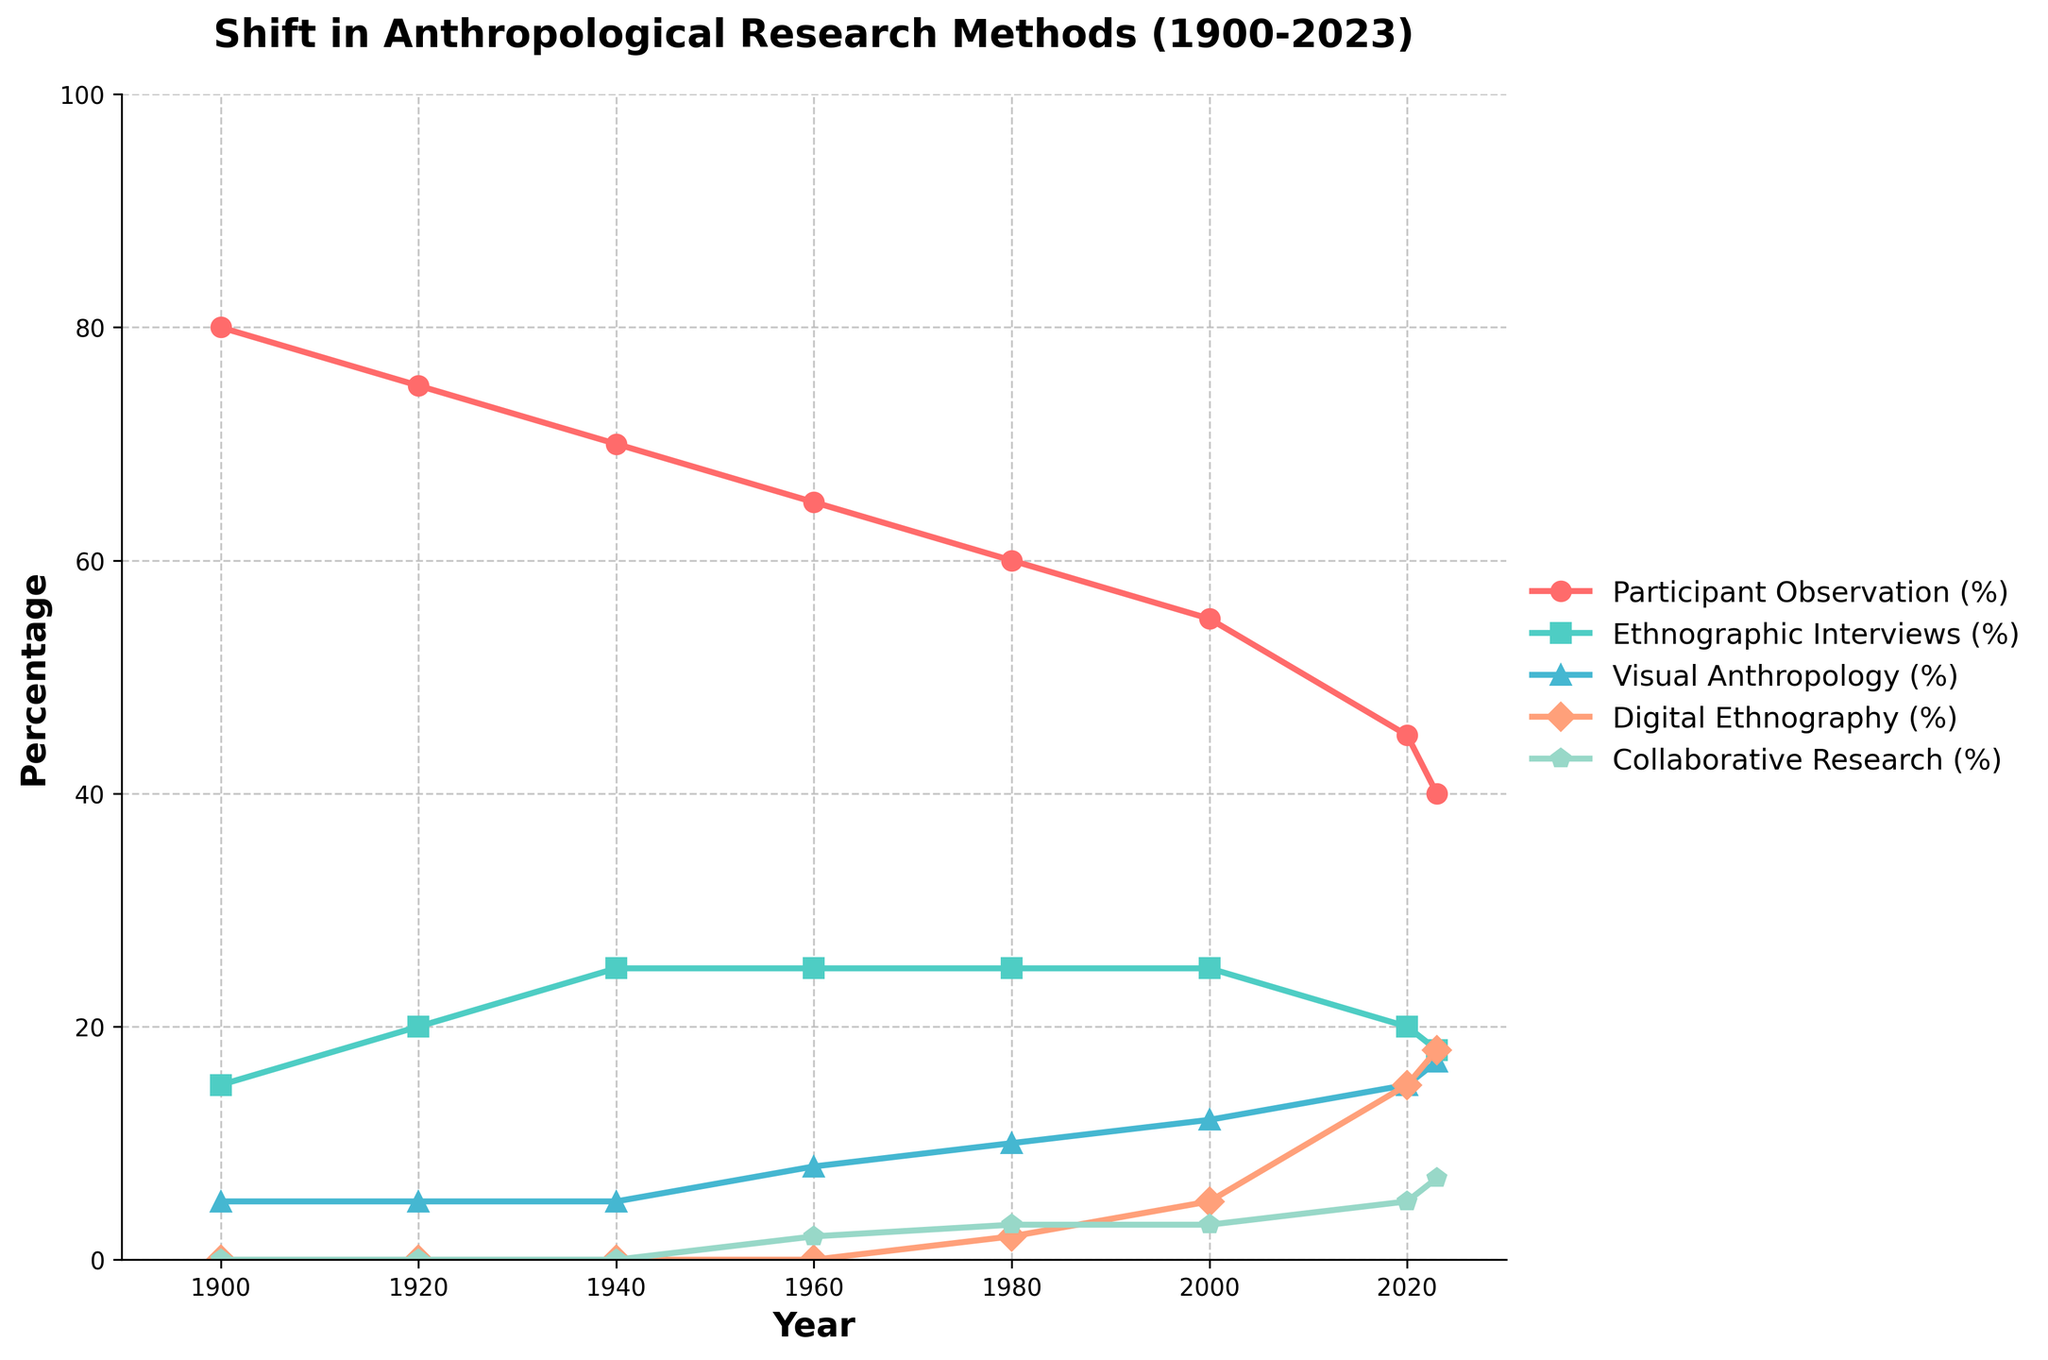Which research method had the highest percentage in 1900? Looking at the figure, the highest percentage in 1900 corresponds to Participant Observation.
Answer: Participant Observation How did the percentage of Ethnographic Interviews change from 1940 to 2023? The percentage of Ethnographic Interviews was 25% in 1940 and decreased to 18% in 2023. The change is 25% - 18% = 7%.
Answer: Decreased by 7% In which year did Visual Anthropology reach 15%? The visual mark for Visual Anthropology reaches 15% in the year 2020.
Answer: 2020 Compare the percentages of Participant Observation and Digital Ethnography in 2023. Which is higher and by how much? Participant Observation is at 40%, and Digital Ethnography is at 18% in 2023. The difference is 40% - 18% = 22%.
Answer: Participant Observation is higher by 22% Calculate the average percentage of Digital Ethnography from 1980 to 2023. The percentages for Digital Ethnography are 2%, 5%, 15%, and 18%. The average is (2 + 5 + 15 + 18) / 4 = 10%.
Answer: 10% Which method showed a consistent increase from 1960 to 2023? Collaborative Research showed a steady increase from 2% in 1960 to 7% in 2023.
Answer: Collaborative Research Visual question: What color represents Ethnographic Interviews on the plot? The figure shows that Ethnographic Interviews are represented by the color green.
Answer: Green What is the difference between the highest and lowest percentage values in 2023? The highest percentage in 2023 is Participant Observation at 40%, and the lowest is Ethnographic Interviews at 18%. The difference is 40% - 18% = 22%.
Answer: 22% In which year did Collaborative Research first appear on the chart? Collaborative Research first appears in the year 1960 with a percentage of 2%.
Answer: 1960 